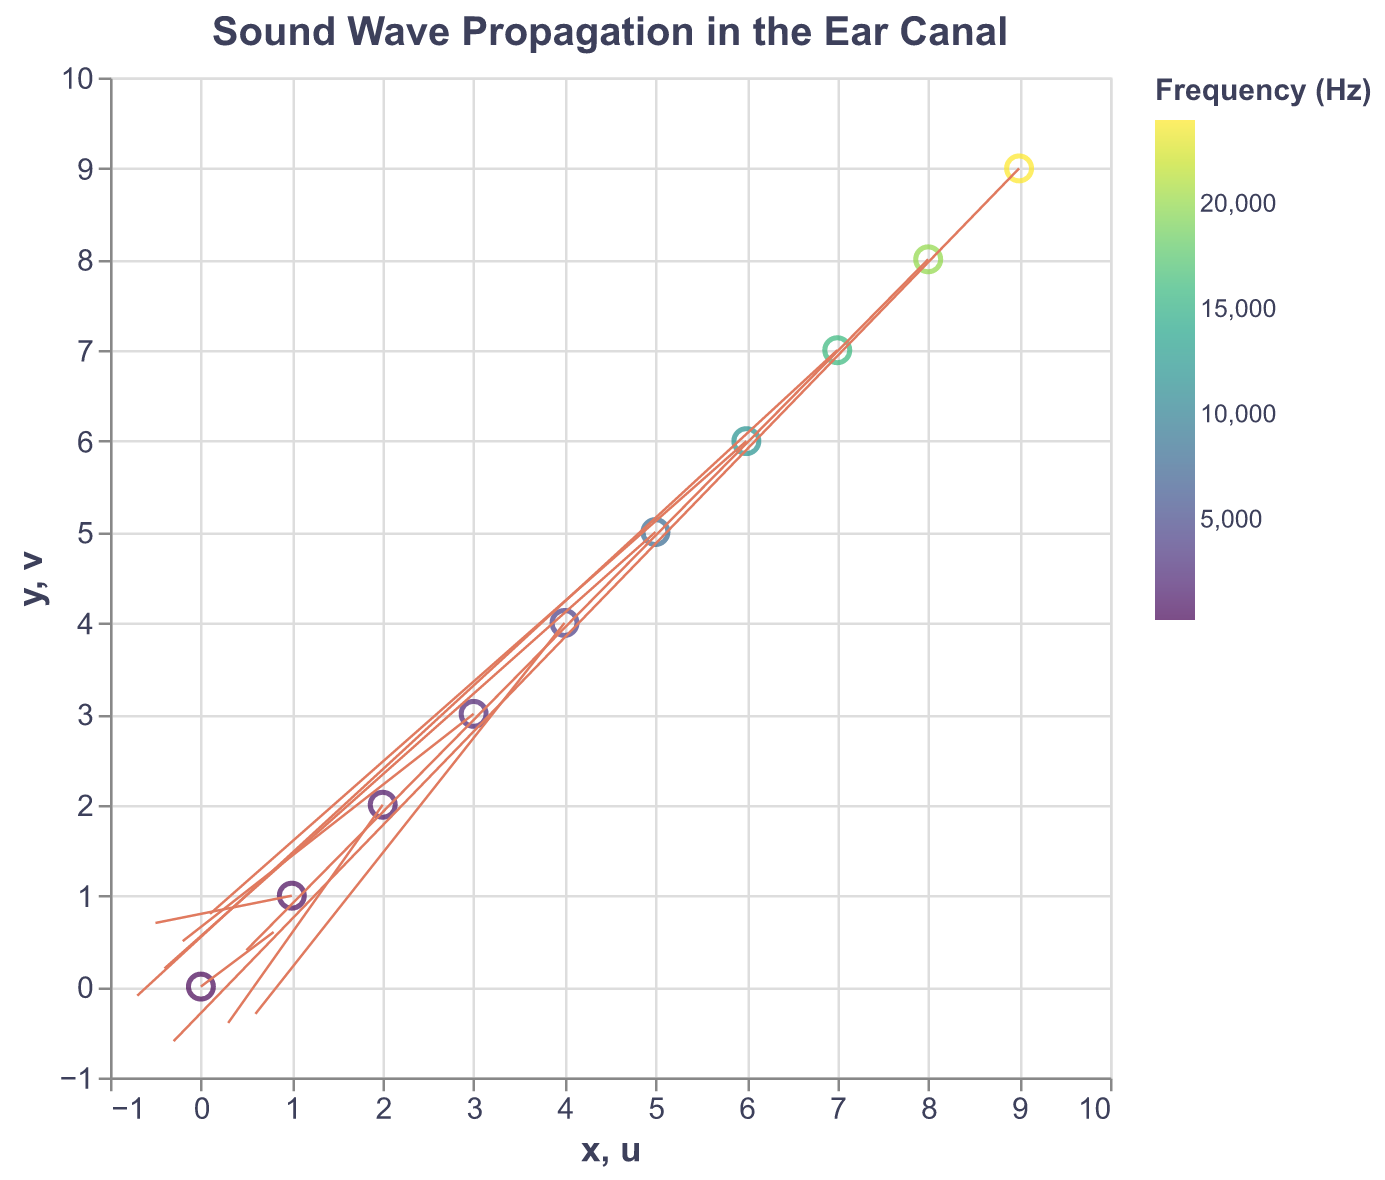What's the title of the figure? The title of the figure is typically displayed at the top center of the plot. In this case, it is "Sound Wave Propagation in the Ear Canal".
Answer: Sound Wave Propagation in the Ear Canal How many data points are plotted in the figure? Each data point in a quiver plot corresponds to a vector and a point on the graph. Counting the points, we find there are 10 such vectors.
Answer: 10 Which frequency is associated with the vector at the point (4, 4)? The data point at (4, 4) is associated with a frequency that is color-coded in the legend. It corresponds to the entry {"x": 4, "y": 4, "u": 0.6, "v": -0.3, "frequency": 4000}.
Answer: 4000 What colors are used to represent different frequencies? The frequencies are visually represented with colors from a color scheme called "viridis," ranging from dark blue to yellow. This helps to visually differentiate the different frequency values.
Answer: Dark blue to yellow What's the direction of the vector at the point (7, 7)? The vector at the point (7, 7) is defined by a direction given by (u, v). Looking at the data, the vector is (-0.7, -0.1), which means it points to the left and slightly downwards.
Answer: Left and slightly downwards Which vector has the largest magnitude? To find the vector with the largest magnitude, we calculate the magnitude for each vector using the formula √(u^2 + v^2). The vector with the coordinates (0.1, 0.8) has the largest magnitude which occurs at the point (6, 6).
Answer: (0.1, 0.8) at the point (6, 6) At which point does the vector point upward and to the right? A vector points upward and to the right if both u and v are positive. This condition is met at the point (0, 0) where (u, v) is (0.8, 0.6) and (8, 8) where (u, v) is (0.5, 0.4).
Answer: (0, 0) and (8, 8) Which two points have vectors with opposite directions? To find vectors with opposite directions, we look for points where the signs of u and v are reversed. The points (1, 1) - (0.5, 0.7) and (7, 7) - (-0.7, -0.1) have vectors with directly opposite directions.
Answer: (1, 1) and (7, 7) Which vector represents the highest frequency? The highest frequency in the data is 24000 Hz, associated with the vector at point (9, 9) with (u, v) = (-0.3, -0.6).
Answer: (9, 9) 